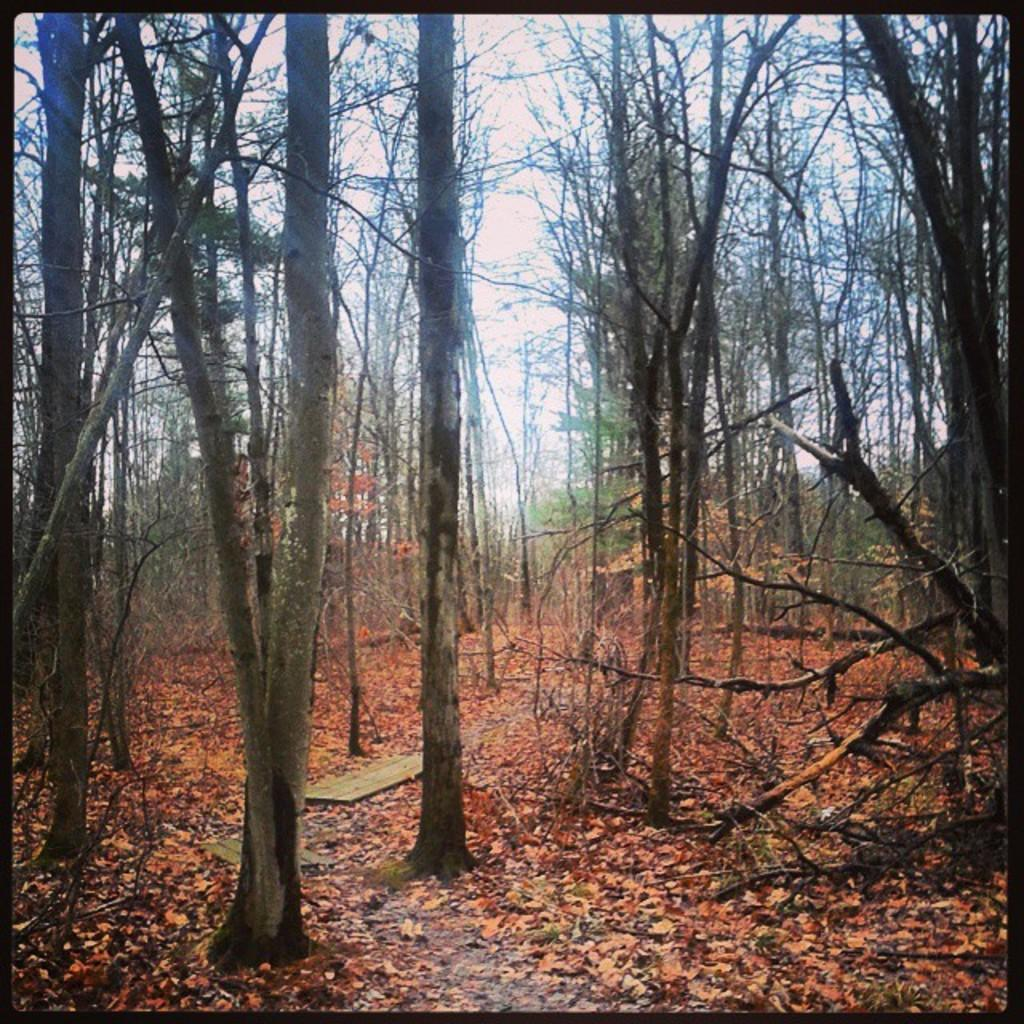What type of vegetation can be seen in the image? There are trees in the image. What is present on the ground beneath the trees? There are fallen leaves on the land in the image. What part of the natural environment is visible in the image? The sky is visible in the image. What feature surrounds the image? The image has borders. Can you see the eye of the person walking through the trees in the image? There is no person or eye visible in the image; it only features trees, fallen leaves, the sky, and borders. 